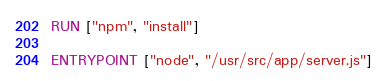<code> <loc_0><loc_0><loc_500><loc_500><_Dockerfile_>RUN ["npm", "install"]

ENTRYPOINT ["node", "/usr/src/app/server.js"]
</code> 